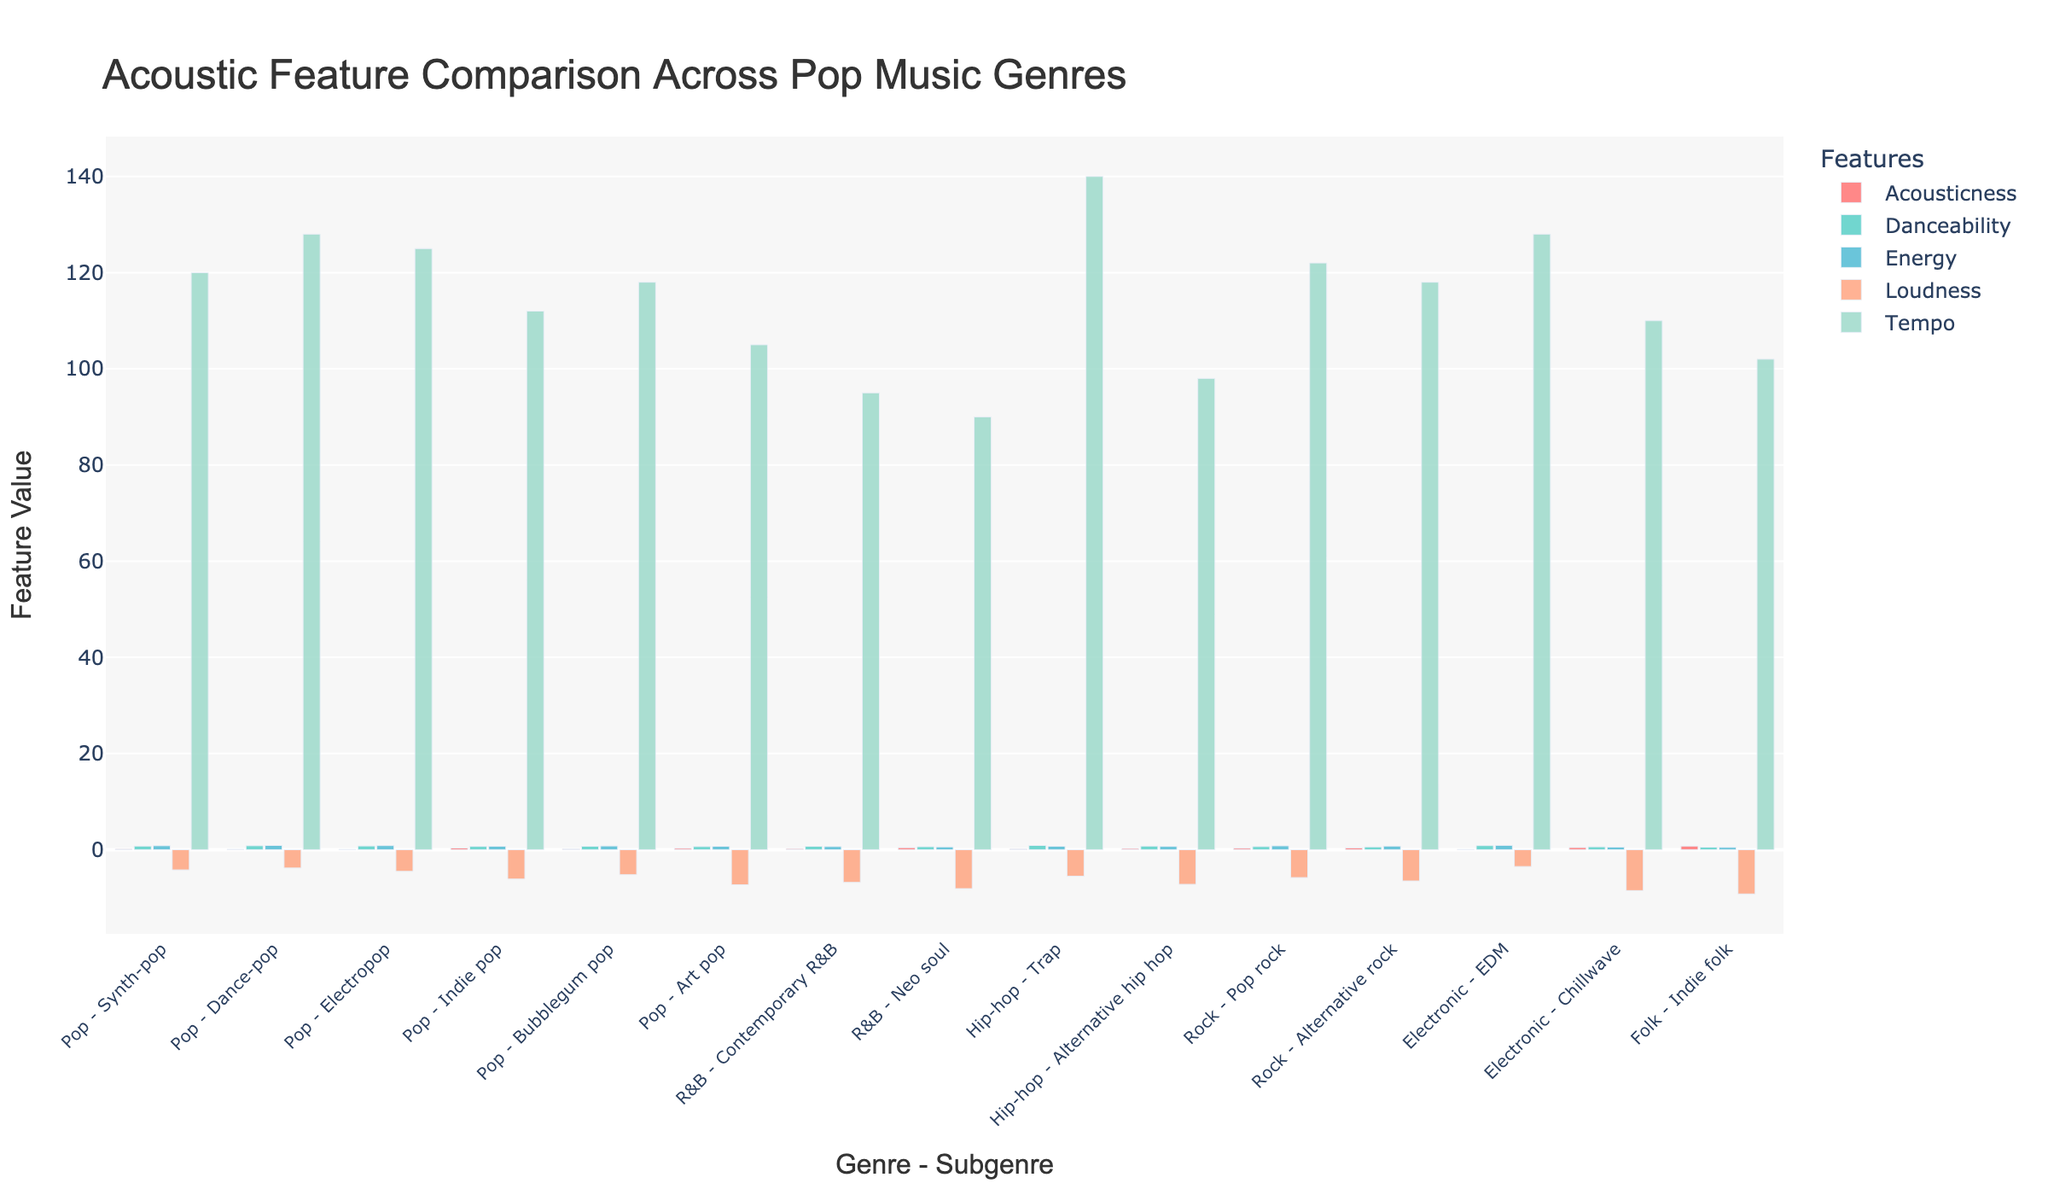what is the title of the plot? The title is at the top of the figure, formatted in a larger font and specifies the overall subject of the plot: 'Acoustic Feature Comparison Across Pop Music Genres'
Answer: Acoustic Feature Comparison Across Pop Music Genres what feature has the highest value for Synth-pop? Identify the bar associated with Synth-pop and compare the heights of the bars representing each feature for this subgenre to determine the tallest one.
Answer: Danceability Which subgenre has the lowest energy value, and what is it? Compare the heights of the bars for the Energy feature across all subgenres to find the lowest one.
Answer: Chillwave, 0.55 What is the difference in danceability between Dance-pop and Chillwave? Find the Danceability values for both Dance-pop and Chillwave, then compute the difference: 0.82 - 0.60 = 0.22
Answer: 0.22 Which subgenre under the Electronic genre has higher Loudness? Compare the Loudness values of the subgenres under the Electronic genre (EDM and Chillwave) and see which one is higher. EDM has -3.5, which is higher than Chillwave's -8.5 as values of Loudness are negative.
Answer: EDM What subgenre in the Pop genre has the highest Tempo? Among all Pop subgenres, compare the bars for Tempo and identify the one with the highest value.
Answer: Dance-pop What is the sum of Acousticness for all subgenres under the Rock genre? Add the Acousticness values for Pop rock (0.30) and Alternative rock (0.38): 0.30 + 0.38 = 0.68
Answer: 0.68 Which feature shows the greatest variation in values across all subgenres? Visually assess the range (difference between the highest and lowest values) for each feature across all subgenres. Energy ranges from 0.48 to 0.90.
Answer: Energy 